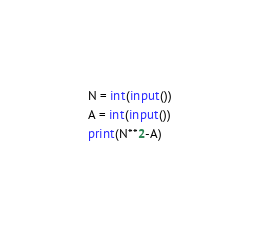Convert code to text. <code><loc_0><loc_0><loc_500><loc_500><_Python_>N = int(input())
A = int(input())
print(N**2-A)</code> 